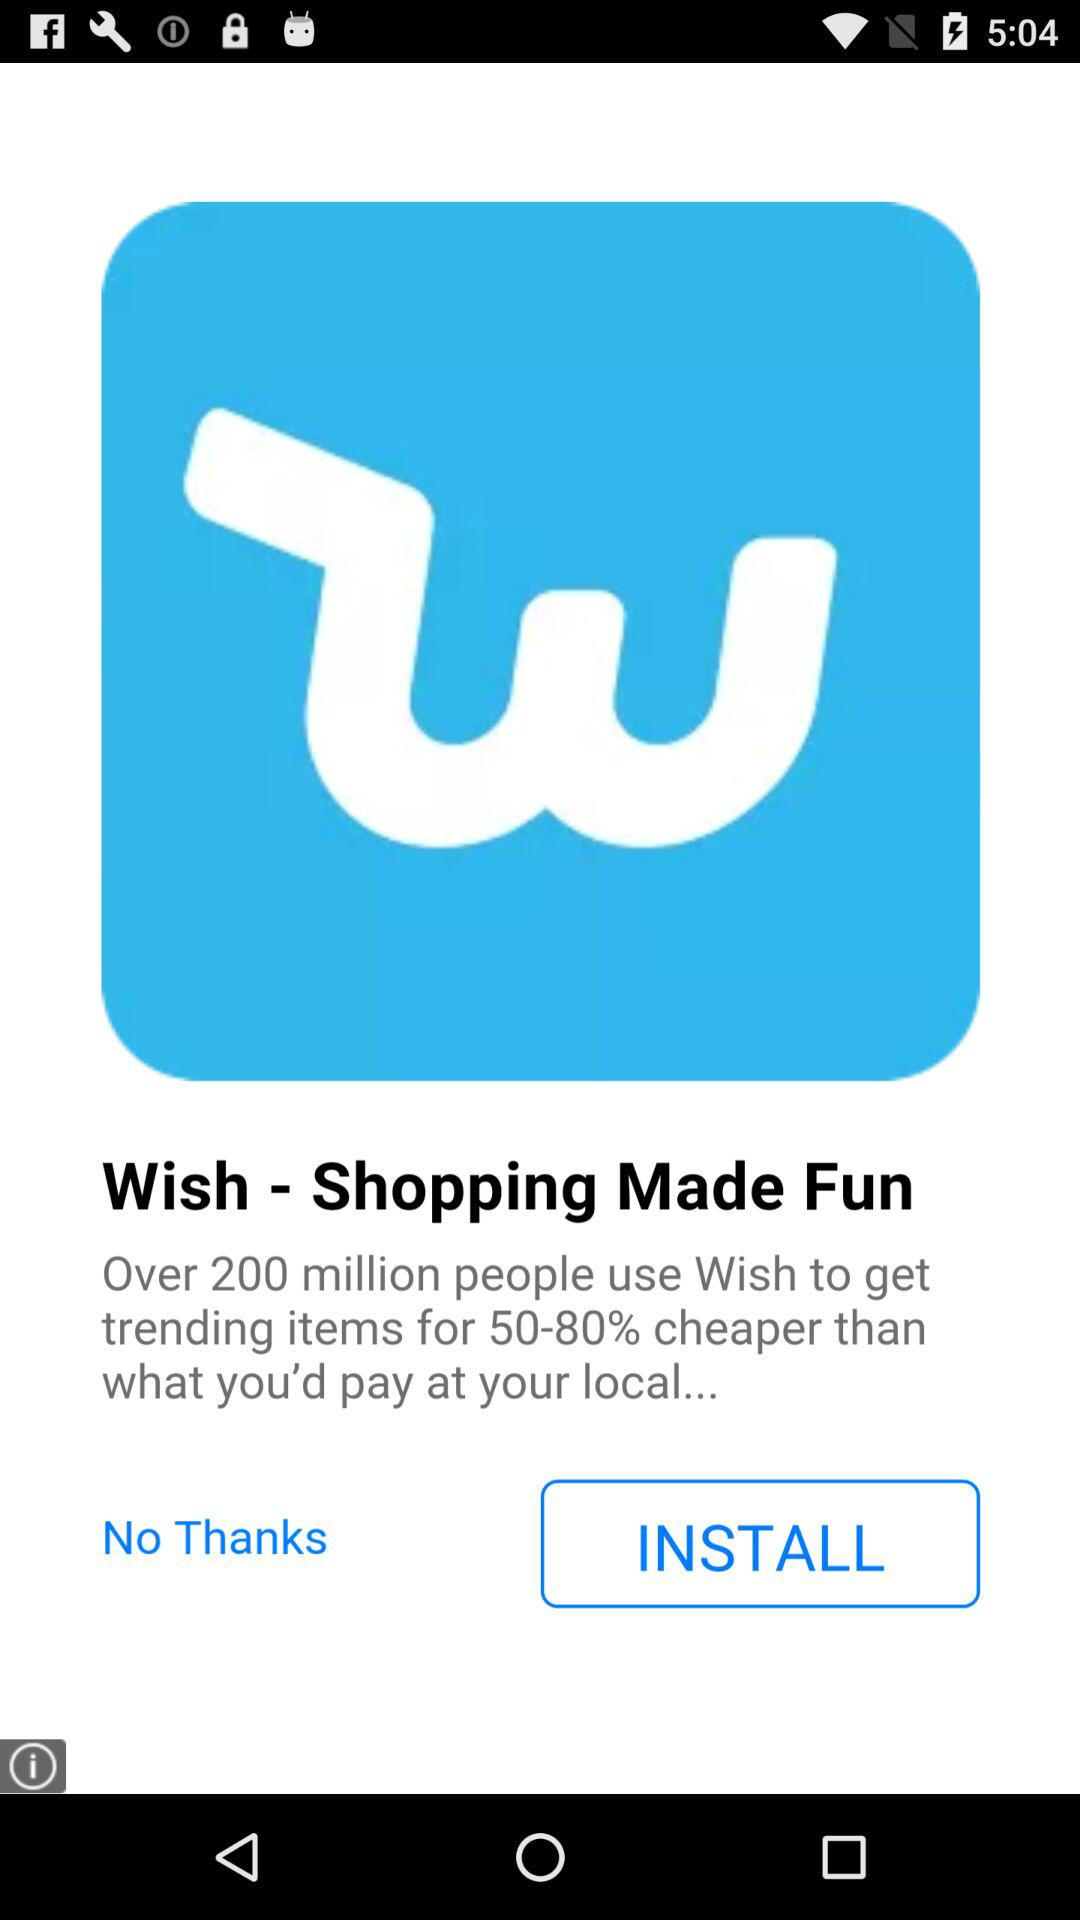What version of "Wish" is being used?
When the provided information is insufficient, respond with <no answer>. <no answer> 